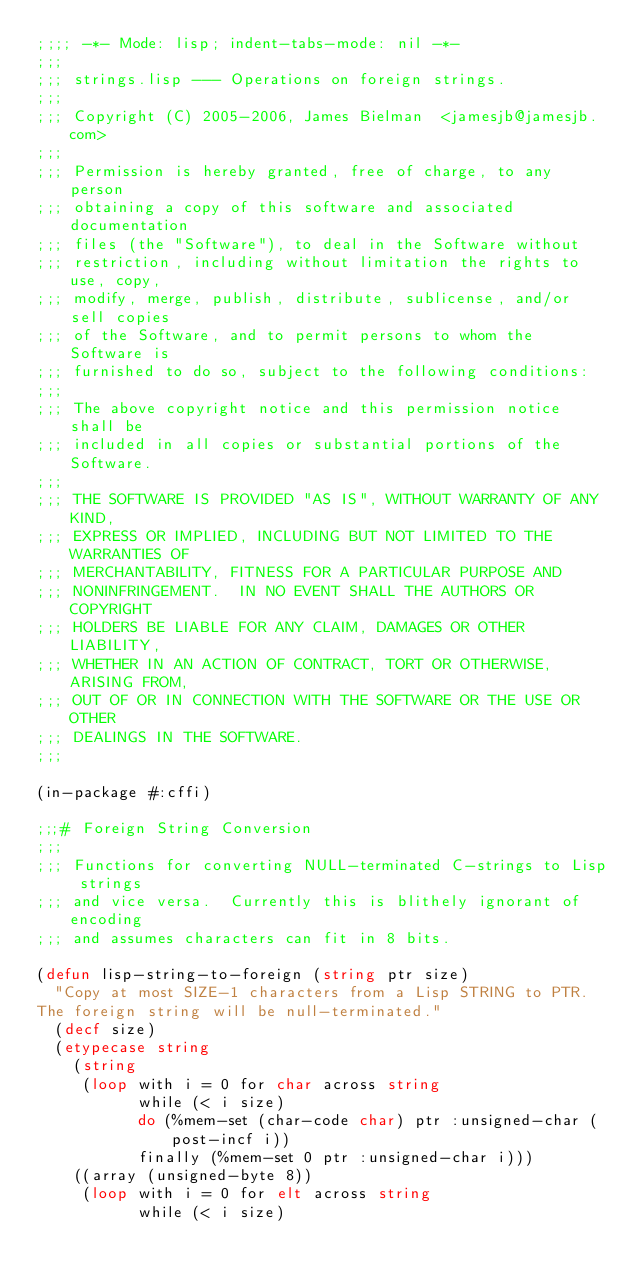<code> <loc_0><loc_0><loc_500><loc_500><_Lisp_>;;;; -*- Mode: lisp; indent-tabs-mode: nil -*-
;;;
;;; strings.lisp --- Operations on foreign strings.
;;;
;;; Copyright (C) 2005-2006, James Bielman  <jamesjb@jamesjb.com>
;;;
;;; Permission is hereby granted, free of charge, to any person
;;; obtaining a copy of this software and associated documentation
;;; files (the "Software"), to deal in the Software without
;;; restriction, including without limitation the rights to use, copy,
;;; modify, merge, publish, distribute, sublicense, and/or sell copies
;;; of the Software, and to permit persons to whom the Software is
;;; furnished to do so, subject to the following conditions:
;;;
;;; The above copyright notice and this permission notice shall be
;;; included in all copies or substantial portions of the Software.
;;;
;;; THE SOFTWARE IS PROVIDED "AS IS", WITHOUT WARRANTY OF ANY KIND,
;;; EXPRESS OR IMPLIED, INCLUDING BUT NOT LIMITED TO THE WARRANTIES OF
;;; MERCHANTABILITY, FITNESS FOR A PARTICULAR PURPOSE AND
;;; NONINFRINGEMENT.  IN NO EVENT SHALL THE AUTHORS OR COPYRIGHT
;;; HOLDERS BE LIABLE FOR ANY CLAIM, DAMAGES OR OTHER LIABILITY,
;;; WHETHER IN AN ACTION OF CONTRACT, TORT OR OTHERWISE, ARISING FROM,
;;; OUT OF OR IN CONNECTION WITH THE SOFTWARE OR THE USE OR OTHER
;;; DEALINGS IN THE SOFTWARE.
;;;

(in-package #:cffi)

;;;# Foreign String Conversion
;;;
;;; Functions for converting NULL-terminated C-strings to Lisp strings
;;; and vice versa.  Currently this is blithely ignorant of encoding
;;; and assumes characters can fit in 8 bits.

(defun lisp-string-to-foreign (string ptr size)
  "Copy at most SIZE-1 characters from a Lisp STRING to PTR.
The foreign string will be null-terminated."
  (decf size)
  (etypecase string
    (string
     (loop with i = 0 for char across string
           while (< i size)
           do (%mem-set (char-code char) ptr :unsigned-char (post-incf i))
           finally (%mem-set 0 ptr :unsigned-char i)))
    ((array (unsigned-byte 8))
     (loop with i = 0 for elt across string
           while (< i size)</code> 